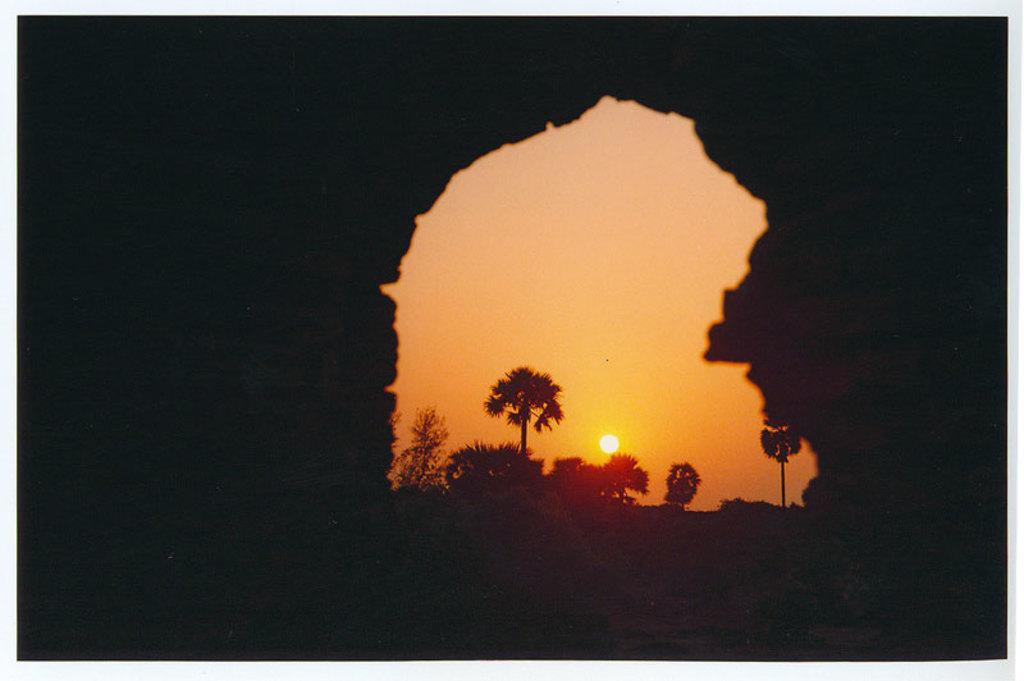In one or two sentences, can you explain what this image depicts? In this image I can see few trees, background I can see sun, and sky is in orange and yellow color. 